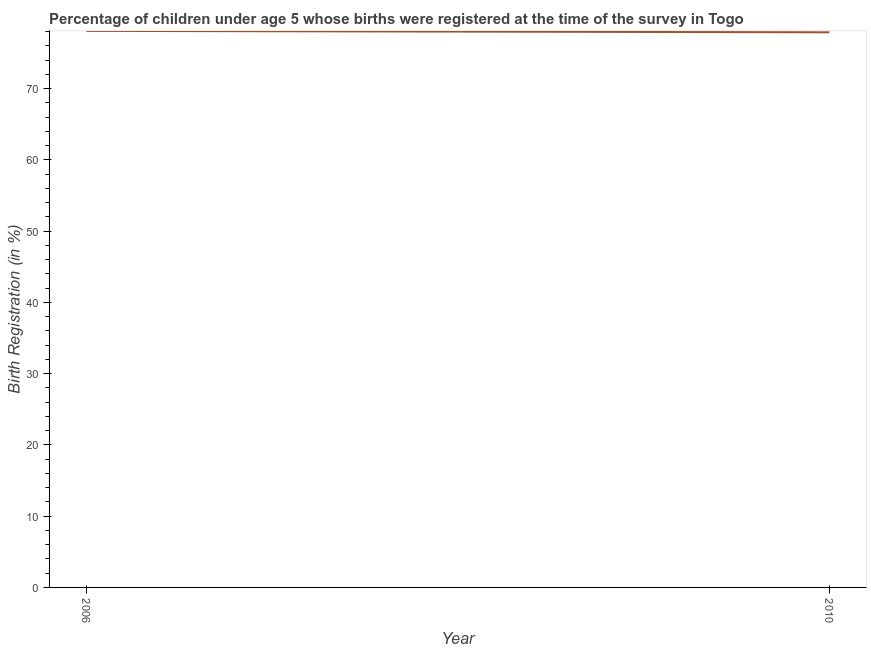What is the birth registration in 2010?
Ensure brevity in your answer.  77.9. Across all years, what is the maximum birth registration?
Offer a very short reply. 78.1. Across all years, what is the minimum birth registration?
Your answer should be compact. 77.9. In which year was the birth registration maximum?
Make the answer very short. 2006. What is the sum of the birth registration?
Make the answer very short. 156. What is the difference between the birth registration in 2006 and 2010?
Give a very brief answer. 0.2. What is the average birth registration per year?
Make the answer very short. 78. What is the ratio of the birth registration in 2006 to that in 2010?
Make the answer very short. 1. Is the birth registration in 2006 less than that in 2010?
Provide a succinct answer. No. What is the difference between two consecutive major ticks on the Y-axis?
Provide a succinct answer. 10. Are the values on the major ticks of Y-axis written in scientific E-notation?
Make the answer very short. No. Does the graph contain any zero values?
Your answer should be compact. No. Does the graph contain grids?
Offer a very short reply. No. What is the title of the graph?
Offer a terse response. Percentage of children under age 5 whose births were registered at the time of the survey in Togo. What is the label or title of the Y-axis?
Make the answer very short. Birth Registration (in %). What is the Birth Registration (in %) of 2006?
Your answer should be very brief. 78.1. What is the Birth Registration (in %) of 2010?
Your answer should be compact. 77.9. What is the ratio of the Birth Registration (in %) in 2006 to that in 2010?
Make the answer very short. 1. 